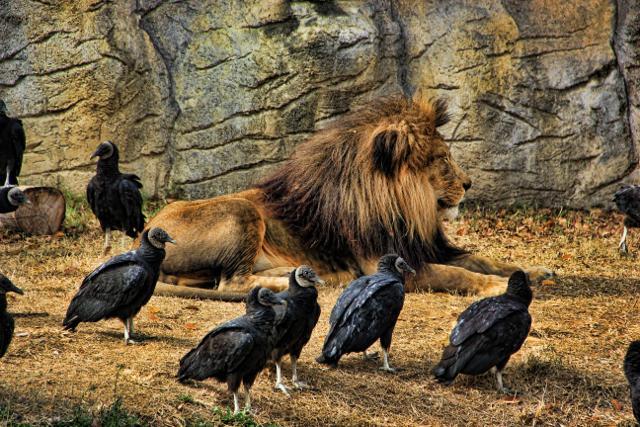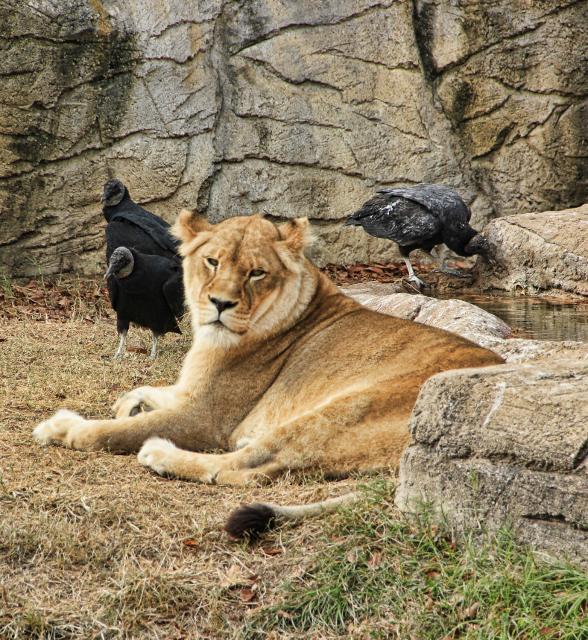The first image is the image on the left, the second image is the image on the right. Considering the images on both sides, is "At least one image shows an apparently living mammal surrounded by vultures." valid? Answer yes or no. Yes. The first image is the image on the left, the second image is the image on the right. For the images displayed, is the sentence "There are two kinds of bird in the image on the left." factually correct? Answer yes or no. No. 